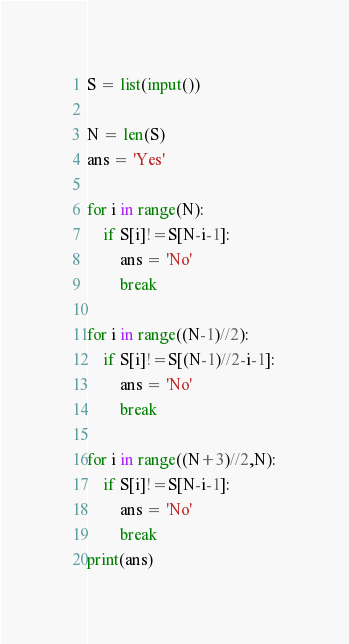<code> <loc_0><loc_0><loc_500><loc_500><_Python_>S = list(input())

N = len(S)
ans = 'Yes'

for i in range(N):
    if S[i]!=S[N-i-1]:
        ans = 'No'
        break

for i in range((N-1)//2):
    if S[i]!=S[(N-1)//2-i-1]:
        ans = 'No'
        break

for i in range((N+3)//2,N):
    if S[i]!=S[N-i-1]:
        ans = 'No'
        break
print(ans)</code> 